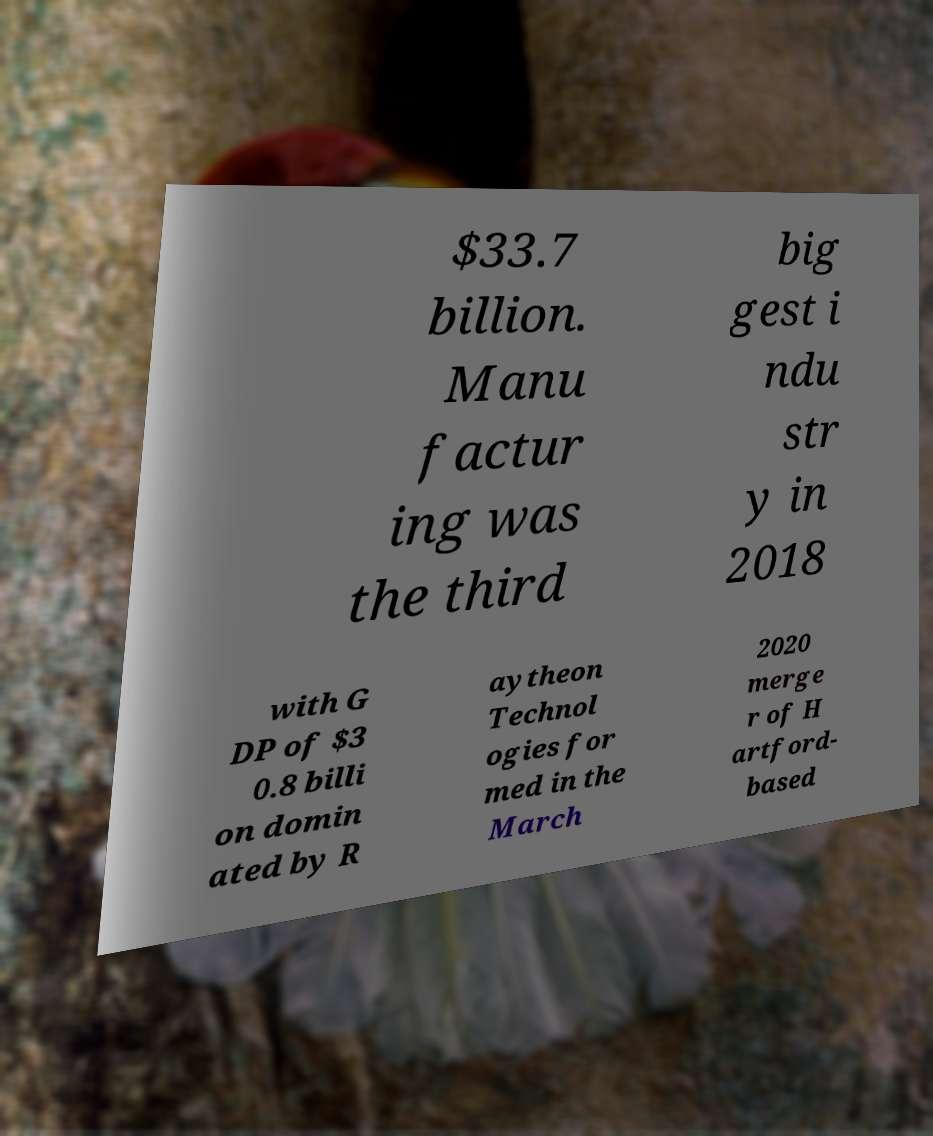Could you extract and type out the text from this image? $33.7 billion. Manu factur ing was the third big gest i ndu str y in 2018 with G DP of $3 0.8 billi on domin ated by R aytheon Technol ogies for med in the March 2020 merge r of H artford- based 